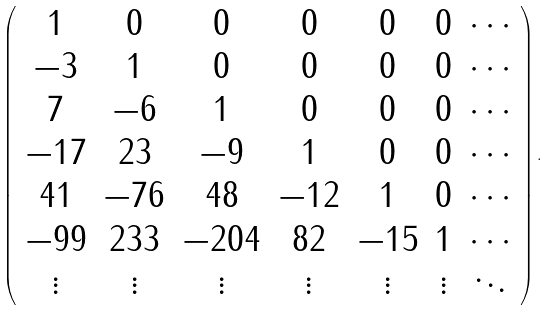<formula> <loc_0><loc_0><loc_500><loc_500>\left ( \begin{array} { c c c c c c c } 1 & 0 & 0 & 0 & 0 & 0 & \cdots \\ - 3 & 1 & 0 & 0 & 0 & 0 & \cdots \\ 7 & - 6 & 1 & 0 & 0 & 0 & \cdots \\ - 1 7 & 2 3 & - 9 & 1 & 0 & 0 & \cdots \\ 4 1 & - 7 6 & 4 8 & - 1 2 & 1 & 0 & \cdots \\ - 9 9 & 2 3 3 & - 2 0 4 & 8 2 & - 1 5 & 1 & \cdots \\ \vdots & \vdots & \vdots & \vdots & \vdots & \vdots & \ddots \end{array} \right ) .</formula> 